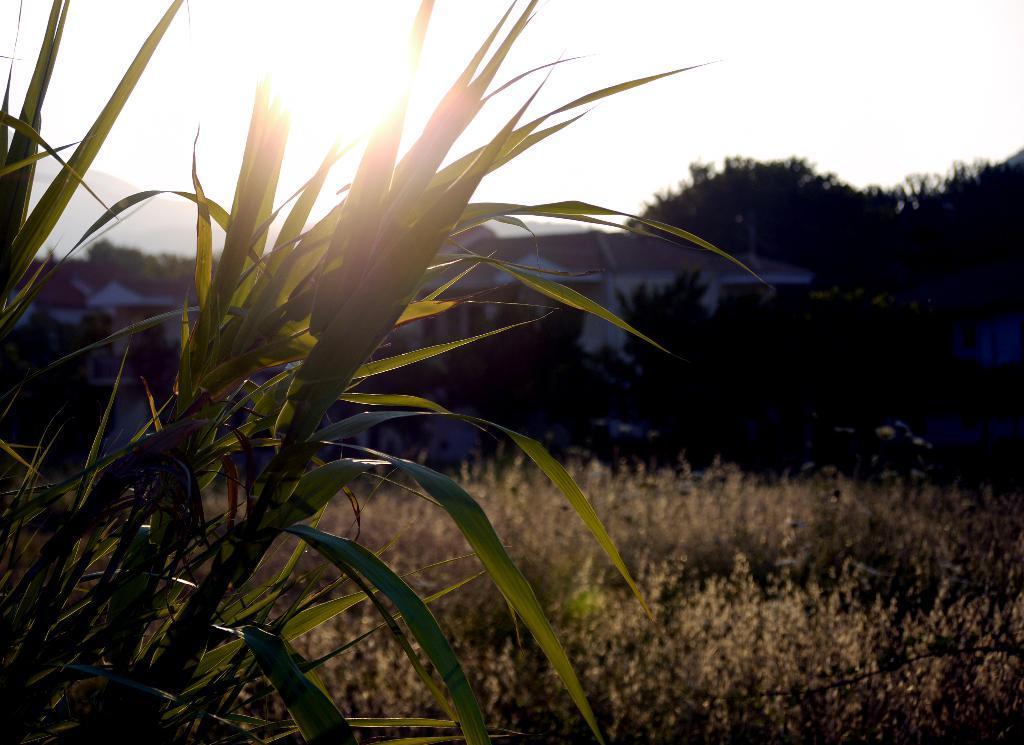In one or two sentences, can you explain what this image depicts? In this image we can see the mountains, some houses, some trees, bushes, plants and grass on the surface. At the top there is the sunlight in the sky. 